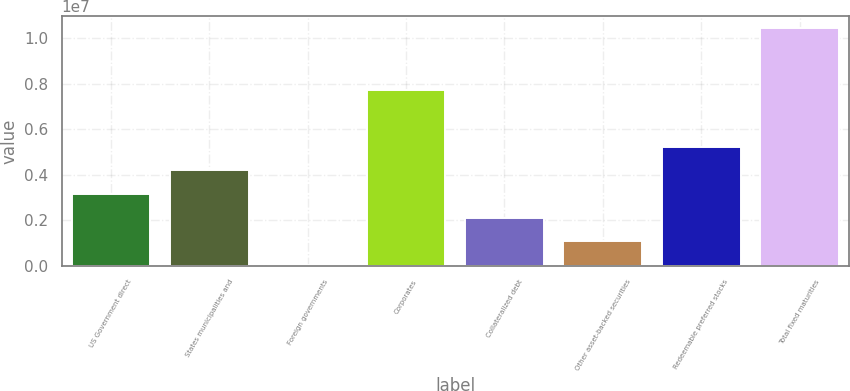<chart> <loc_0><loc_0><loc_500><loc_500><bar_chart><fcel>US Government direct<fcel>States municipalities and<fcel>Foreign governments<fcel>Corporates<fcel>Collateralized debt<fcel>Other asset-backed securities<fcel>Redeemable preferred stocks<fcel>Total fixed maturities<nl><fcel>3.1463e+06<fcel>4.18761e+06<fcel>22352<fcel>7.70794e+06<fcel>2.10498e+06<fcel>1.06367e+06<fcel>5.22892e+06<fcel>1.04355e+07<nl></chart> 